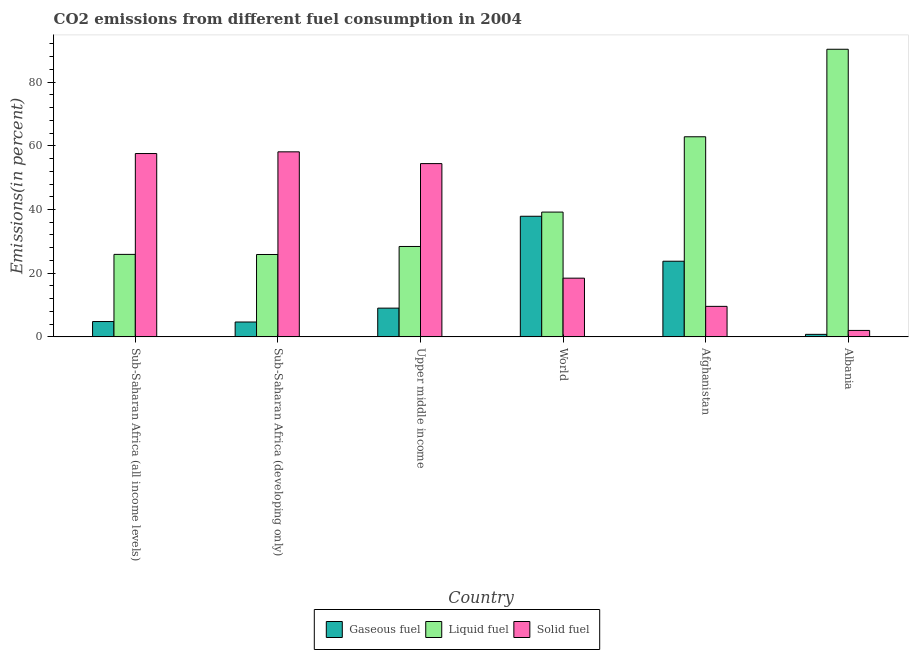How many different coloured bars are there?
Your response must be concise. 3. Are the number of bars per tick equal to the number of legend labels?
Give a very brief answer. Yes. What is the label of the 5th group of bars from the left?
Your answer should be compact. Afghanistan. In how many cases, is the number of bars for a given country not equal to the number of legend labels?
Provide a succinct answer. 0. What is the percentage of gaseous fuel emission in World?
Keep it short and to the point. 37.87. Across all countries, what is the maximum percentage of gaseous fuel emission?
Offer a terse response. 37.87. Across all countries, what is the minimum percentage of liquid fuel emission?
Your answer should be very brief. 25.87. In which country was the percentage of gaseous fuel emission maximum?
Your answer should be compact. World. In which country was the percentage of gaseous fuel emission minimum?
Keep it short and to the point. Albania. What is the total percentage of gaseous fuel emission in the graph?
Your response must be concise. 80.92. What is the difference between the percentage of liquid fuel emission in Albania and that in Sub-Saharan Africa (all income levels)?
Give a very brief answer. 64.41. What is the difference between the percentage of liquid fuel emission in Sub-Saharan Africa (all income levels) and the percentage of solid fuel emission in Upper middle income?
Your answer should be compact. -28.51. What is the average percentage of solid fuel emission per country?
Make the answer very short. 33.35. What is the difference between the percentage of gaseous fuel emission and percentage of liquid fuel emission in Sub-Saharan Africa (all income levels)?
Give a very brief answer. -21.09. What is the ratio of the percentage of gaseous fuel emission in Sub-Saharan Africa (all income levels) to that in World?
Offer a very short reply. 0.13. What is the difference between the highest and the second highest percentage of solid fuel emission?
Ensure brevity in your answer.  0.53. What is the difference between the highest and the lowest percentage of liquid fuel emission?
Ensure brevity in your answer.  64.45. Is the sum of the percentage of liquid fuel emission in Afghanistan and Albania greater than the maximum percentage of solid fuel emission across all countries?
Offer a terse response. Yes. What does the 3rd bar from the left in Albania represents?
Your response must be concise. Solid fuel. What does the 1st bar from the right in Sub-Saharan Africa (developing only) represents?
Offer a terse response. Solid fuel. Is it the case that in every country, the sum of the percentage of gaseous fuel emission and percentage of liquid fuel emission is greater than the percentage of solid fuel emission?
Your answer should be compact. No. Are all the bars in the graph horizontal?
Provide a short and direct response. No. What is the difference between two consecutive major ticks on the Y-axis?
Provide a short and direct response. 20. Does the graph contain any zero values?
Give a very brief answer. No. Does the graph contain grids?
Give a very brief answer. No. How are the legend labels stacked?
Provide a short and direct response. Horizontal. What is the title of the graph?
Offer a very short reply. CO2 emissions from different fuel consumption in 2004. Does "Machinery" appear as one of the legend labels in the graph?
Offer a terse response. No. What is the label or title of the Y-axis?
Make the answer very short. Emissions(in percent). What is the Emissions(in percent) of Gaseous fuel in Sub-Saharan Africa (all income levels)?
Make the answer very short. 4.81. What is the Emissions(in percent) in Liquid fuel in Sub-Saharan Africa (all income levels)?
Keep it short and to the point. 25.9. What is the Emissions(in percent) of Solid fuel in Sub-Saharan Africa (all income levels)?
Your response must be concise. 57.57. What is the Emissions(in percent) of Gaseous fuel in Sub-Saharan Africa (developing only)?
Provide a short and direct response. 4.67. What is the Emissions(in percent) in Liquid fuel in Sub-Saharan Africa (developing only)?
Provide a short and direct response. 25.87. What is the Emissions(in percent) in Solid fuel in Sub-Saharan Africa (developing only)?
Offer a terse response. 58.11. What is the Emissions(in percent) in Gaseous fuel in Upper middle income?
Ensure brevity in your answer.  9.03. What is the Emissions(in percent) in Liquid fuel in Upper middle income?
Keep it short and to the point. 28.38. What is the Emissions(in percent) of Solid fuel in Upper middle income?
Give a very brief answer. 54.41. What is the Emissions(in percent) in Gaseous fuel in World?
Your answer should be compact. 37.87. What is the Emissions(in percent) of Liquid fuel in World?
Provide a succinct answer. 39.18. What is the Emissions(in percent) in Solid fuel in World?
Make the answer very short. 18.44. What is the Emissions(in percent) of Gaseous fuel in Afghanistan?
Offer a very short reply. 23.75. What is the Emissions(in percent) in Liquid fuel in Afghanistan?
Ensure brevity in your answer.  62.84. What is the Emissions(in percent) of Solid fuel in Afghanistan?
Offer a terse response. 9.58. What is the Emissions(in percent) of Gaseous fuel in Albania?
Give a very brief answer. 0.79. What is the Emissions(in percent) of Liquid fuel in Albania?
Your answer should be very brief. 90.32. What is the Emissions(in percent) of Solid fuel in Albania?
Ensure brevity in your answer.  2.02. Across all countries, what is the maximum Emissions(in percent) in Gaseous fuel?
Offer a very short reply. 37.87. Across all countries, what is the maximum Emissions(in percent) in Liquid fuel?
Your answer should be compact. 90.32. Across all countries, what is the maximum Emissions(in percent) in Solid fuel?
Provide a succinct answer. 58.11. Across all countries, what is the minimum Emissions(in percent) in Gaseous fuel?
Offer a terse response. 0.79. Across all countries, what is the minimum Emissions(in percent) of Liquid fuel?
Your answer should be compact. 25.87. Across all countries, what is the minimum Emissions(in percent) in Solid fuel?
Give a very brief answer. 2.02. What is the total Emissions(in percent) in Gaseous fuel in the graph?
Keep it short and to the point. 80.92. What is the total Emissions(in percent) in Liquid fuel in the graph?
Your response must be concise. 272.49. What is the total Emissions(in percent) in Solid fuel in the graph?
Offer a very short reply. 200.13. What is the difference between the Emissions(in percent) of Gaseous fuel in Sub-Saharan Africa (all income levels) and that in Sub-Saharan Africa (developing only)?
Make the answer very short. 0.15. What is the difference between the Emissions(in percent) of Liquid fuel in Sub-Saharan Africa (all income levels) and that in Sub-Saharan Africa (developing only)?
Ensure brevity in your answer.  0.03. What is the difference between the Emissions(in percent) of Solid fuel in Sub-Saharan Africa (all income levels) and that in Sub-Saharan Africa (developing only)?
Provide a short and direct response. -0.53. What is the difference between the Emissions(in percent) in Gaseous fuel in Sub-Saharan Africa (all income levels) and that in Upper middle income?
Your answer should be very brief. -4.21. What is the difference between the Emissions(in percent) of Liquid fuel in Sub-Saharan Africa (all income levels) and that in Upper middle income?
Ensure brevity in your answer.  -2.48. What is the difference between the Emissions(in percent) in Solid fuel in Sub-Saharan Africa (all income levels) and that in Upper middle income?
Offer a very short reply. 3.16. What is the difference between the Emissions(in percent) of Gaseous fuel in Sub-Saharan Africa (all income levels) and that in World?
Your response must be concise. -33.06. What is the difference between the Emissions(in percent) of Liquid fuel in Sub-Saharan Africa (all income levels) and that in World?
Provide a short and direct response. -13.28. What is the difference between the Emissions(in percent) in Solid fuel in Sub-Saharan Africa (all income levels) and that in World?
Offer a very short reply. 39.14. What is the difference between the Emissions(in percent) of Gaseous fuel in Sub-Saharan Africa (all income levels) and that in Afghanistan?
Ensure brevity in your answer.  -18.94. What is the difference between the Emissions(in percent) of Liquid fuel in Sub-Saharan Africa (all income levels) and that in Afghanistan?
Provide a succinct answer. -36.93. What is the difference between the Emissions(in percent) of Solid fuel in Sub-Saharan Africa (all income levels) and that in Afghanistan?
Your response must be concise. 47.99. What is the difference between the Emissions(in percent) in Gaseous fuel in Sub-Saharan Africa (all income levels) and that in Albania?
Give a very brief answer. 4.02. What is the difference between the Emissions(in percent) in Liquid fuel in Sub-Saharan Africa (all income levels) and that in Albania?
Keep it short and to the point. -64.41. What is the difference between the Emissions(in percent) of Solid fuel in Sub-Saharan Africa (all income levels) and that in Albania?
Ensure brevity in your answer.  55.55. What is the difference between the Emissions(in percent) of Gaseous fuel in Sub-Saharan Africa (developing only) and that in Upper middle income?
Offer a terse response. -4.36. What is the difference between the Emissions(in percent) in Liquid fuel in Sub-Saharan Africa (developing only) and that in Upper middle income?
Your answer should be compact. -2.52. What is the difference between the Emissions(in percent) of Solid fuel in Sub-Saharan Africa (developing only) and that in Upper middle income?
Ensure brevity in your answer.  3.69. What is the difference between the Emissions(in percent) of Gaseous fuel in Sub-Saharan Africa (developing only) and that in World?
Your answer should be compact. -33.21. What is the difference between the Emissions(in percent) of Liquid fuel in Sub-Saharan Africa (developing only) and that in World?
Offer a very short reply. -13.32. What is the difference between the Emissions(in percent) of Solid fuel in Sub-Saharan Africa (developing only) and that in World?
Your response must be concise. 39.67. What is the difference between the Emissions(in percent) of Gaseous fuel in Sub-Saharan Africa (developing only) and that in Afghanistan?
Make the answer very short. -19.09. What is the difference between the Emissions(in percent) of Liquid fuel in Sub-Saharan Africa (developing only) and that in Afghanistan?
Ensure brevity in your answer.  -36.97. What is the difference between the Emissions(in percent) of Solid fuel in Sub-Saharan Africa (developing only) and that in Afghanistan?
Provide a succinct answer. 48.53. What is the difference between the Emissions(in percent) of Gaseous fuel in Sub-Saharan Africa (developing only) and that in Albania?
Give a very brief answer. 3.87. What is the difference between the Emissions(in percent) in Liquid fuel in Sub-Saharan Africa (developing only) and that in Albania?
Your answer should be compact. -64.45. What is the difference between the Emissions(in percent) in Solid fuel in Sub-Saharan Africa (developing only) and that in Albania?
Make the answer very short. 56.08. What is the difference between the Emissions(in percent) in Gaseous fuel in Upper middle income and that in World?
Your answer should be very brief. -28.85. What is the difference between the Emissions(in percent) of Liquid fuel in Upper middle income and that in World?
Provide a short and direct response. -10.8. What is the difference between the Emissions(in percent) of Solid fuel in Upper middle income and that in World?
Offer a terse response. 35.98. What is the difference between the Emissions(in percent) of Gaseous fuel in Upper middle income and that in Afghanistan?
Offer a very short reply. -14.73. What is the difference between the Emissions(in percent) of Liquid fuel in Upper middle income and that in Afghanistan?
Your response must be concise. -34.45. What is the difference between the Emissions(in percent) of Solid fuel in Upper middle income and that in Afghanistan?
Make the answer very short. 44.83. What is the difference between the Emissions(in percent) of Gaseous fuel in Upper middle income and that in Albania?
Offer a terse response. 8.23. What is the difference between the Emissions(in percent) in Liquid fuel in Upper middle income and that in Albania?
Offer a terse response. -61.93. What is the difference between the Emissions(in percent) of Solid fuel in Upper middle income and that in Albania?
Keep it short and to the point. 52.39. What is the difference between the Emissions(in percent) in Gaseous fuel in World and that in Afghanistan?
Your answer should be compact. 14.12. What is the difference between the Emissions(in percent) of Liquid fuel in World and that in Afghanistan?
Keep it short and to the point. -23.65. What is the difference between the Emissions(in percent) of Solid fuel in World and that in Afghanistan?
Make the answer very short. 8.86. What is the difference between the Emissions(in percent) in Gaseous fuel in World and that in Albania?
Your response must be concise. 37.08. What is the difference between the Emissions(in percent) of Liquid fuel in World and that in Albania?
Your response must be concise. -51.13. What is the difference between the Emissions(in percent) in Solid fuel in World and that in Albania?
Provide a succinct answer. 16.41. What is the difference between the Emissions(in percent) in Gaseous fuel in Afghanistan and that in Albania?
Offer a terse response. 22.96. What is the difference between the Emissions(in percent) in Liquid fuel in Afghanistan and that in Albania?
Your answer should be very brief. -27.48. What is the difference between the Emissions(in percent) in Solid fuel in Afghanistan and that in Albania?
Make the answer very short. 7.55. What is the difference between the Emissions(in percent) in Gaseous fuel in Sub-Saharan Africa (all income levels) and the Emissions(in percent) in Liquid fuel in Sub-Saharan Africa (developing only)?
Make the answer very short. -21.05. What is the difference between the Emissions(in percent) of Gaseous fuel in Sub-Saharan Africa (all income levels) and the Emissions(in percent) of Solid fuel in Sub-Saharan Africa (developing only)?
Make the answer very short. -53.29. What is the difference between the Emissions(in percent) of Liquid fuel in Sub-Saharan Africa (all income levels) and the Emissions(in percent) of Solid fuel in Sub-Saharan Africa (developing only)?
Keep it short and to the point. -32.2. What is the difference between the Emissions(in percent) of Gaseous fuel in Sub-Saharan Africa (all income levels) and the Emissions(in percent) of Liquid fuel in Upper middle income?
Ensure brevity in your answer.  -23.57. What is the difference between the Emissions(in percent) in Gaseous fuel in Sub-Saharan Africa (all income levels) and the Emissions(in percent) in Solid fuel in Upper middle income?
Provide a short and direct response. -49.6. What is the difference between the Emissions(in percent) in Liquid fuel in Sub-Saharan Africa (all income levels) and the Emissions(in percent) in Solid fuel in Upper middle income?
Provide a succinct answer. -28.51. What is the difference between the Emissions(in percent) in Gaseous fuel in Sub-Saharan Africa (all income levels) and the Emissions(in percent) in Liquid fuel in World?
Provide a short and direct response. -34.37. What is the difference between the Emissions(in percent) in Gaseous fuel in Sub-Saharan Africa (all income levels) and the Emissions(in percent) in Solid fuel in World?
Your answer should be very brief. -13.62. What is the difference between the Emissions(in percent) in Liquid fuel in Sub-Saharan Africa (all income levels) and the Emissions(in percent) in Solid fuel in World?
Give a very brief answer. 7.47. What is the difference between the Emissions(in percent) of Gaseous fuel in Sub-Saharan Africa (all income levels) and the Emissions(in percent) of Liquid fuel in Afghanistan?
Your answer should be compact. -58.02. What is the difference between the Emissions(in percent) of Gaseous fuel in Sub-Saharan Africa (all income levels) and the Emissions(in percent) of Solid fuel in Afghanistan?
Make the answer very short. -4.77. What is the difference between the Emissions(in percent) of Liquid fuel in Sub-Saharan Africa (all income levels) and the Emissions(in percent) of Solid fuel in Afghanistan?
Your answer should be very brief. 16.32. What is the difference between the Emissions(in percent) of Gaseous fuel in Sub-Saharan Africa (all income levels) and the Emissions(in percent) of Liquid fuel in Albania?
Provide a succinct answer. -85.5. What is the difference between the Emissions(in percent) of Gaseous fuel in Sub-Saharan Africa (all income levels) and the Emissions(in percent) of Solid fuel in Albania?
Your answer should be compact. 2.79. What is the difference between the Emissions(in percent) in Liquid fuel in Sub-Saharan Africa (all income levels) and the Emissions(in percent) in Solid fuel in Albania?
Offer a very short reply. 23.88. What is the difference between the Emissions(in percent) of Gaseous fuel in Sub-Saharan Africa (developing only) and the Emissions(in percent) of Liquid fuel in Upper middle income?
Your answer should be very brief. -23.72. What is the difference between the Emissions(in percent) in Gaseous fuel in Sub-Saharan Africa (developing only) and the Emissions(in percent) in Solid fuel in Upper middle income?
Keep it short and to the point. -49.74. What is the difference between the Emissions(in percent) of Liquid fuel in Sub-Saharan Africa (developing only) and the Emissions(in percent) of Solid fuel in Upper middle income?
Make the answer very short. -28.54. What is the difference between the Emissions(in percent) in Gaseous fuel in Sub-Saharan Africa (developing only) and the Emissions(in percent) in Liquid fuel in World?
Offer a terse response. -34.52. What is the difference between the Emissions(in percent) of Gaseous fuel in Sub-Saharan Africa (developing only) and the Emissions(in percent) of Solid fuel in World?
Offer a terse response. -13.77. What is the difference between the Emissions(in percent) of Liquid fuel in Sub-Saharan Africa (developing only) and the Emissions(in percent) of Solid fuel in World?
Offer a very short reply. 7.43. What is the difference between the Emissions(in percent) of Gaseous fuel in Sub-Saharan Africa (developing only) and the Emissions(in percent) of Liquid fuel in Afghanistan?
Keep it short and to the point. -58.17. What is the difference between the Emissions(in percent) in Gaseous fuel in Sub-Saharan Africa (developing only) and the Emissions(in percent) in Solid fuel in Afghanistan?
Offer a very short reply. -4.91. What is the difference between the Emissions(in percent) of Liquid fuel in Sub-Saharan Africa (developing only) and the Emissions(in percent) of Solid fuel in Afghanistan?
Provide a succinct answer. 16.29. What is the difference between the Emissions(in percent) in Gaseous fuel in Sub-Saharan Africa (developing only) and the Emissions(in percent) in Liquid fuel in Albania?
Keep it short and to the point. -85.65. What is the difference between the Emissions(in percent) of Gaseous fuel in Sub-Saharan Africa (developing only) and the Emissions(in percent) of Solid fuel in Albania?
Keep it short and to the point. 2.64. What is the difference between the Emissions(in percent) in Liquid fuel in Sub-Saharan Africa (developing only) and the Emissions(in percent) in Solid fuel in Albania?
Offer a terse response. 23.84. What is the difference between the Emissions(in percent) in Gaseous fuel in Upper middle income and the Emissions(in percent) in Liquid fuel in World?
Your answer should be compact. -30.16. What is the difference between the Emissions(in percent) of Gaseous fuel in Upper middle income and the Emissions(in percent) of Solid fuel in World?
Your response must be concise. -9.41. What is the difference between the Emissions(in percent) in Liquid fuel in Upper middle income and the Emissions(in percent) in Solid fuel in World?
Provide a succinct answer. 9.95. What is the difference between the Emissions(in percent) in Gaseous fuel in Upper middle income and the Emissions(in percent) in Liquid fuel in Afghanistan?
Offer a very short reply. -53.81. What is the difference between the Emissions(in percent) in Gaseous fuel in Upper middle income and the Emissions(in percent) in Solid fuel in Afghanistan?
Offer a terse response. -0.55. What is the difference between the Emissions(in percent) of Liquid fuel in Upper middle income and the Emissions(in percent) of Solid fuel in Afghanistan?
Make the answer very short. 18.81. What is the difference between the Emissions(in percent) of Gaseous fuel in Upper middle income and the Emissions(in percent) of Liquid fuel in Albania?
Give a very brief answer. -81.29. What is the difference between the Emissions(in percent) in Gaseous fuel in Upper middle income and the Emissions(in percent) in Solid fuel in Albania?
Offer a very short reply. 7. What is the difference between the Emissions(in percent) in Liquid fuel in Upper middle income and the Emissions(in percent) in Solid fuel in Albania?
Give a very brief answer. 26.36. What is the difference between the Emissions(in percent) in Gaseous fuel in World and the Emissions(in percent) in Liquid fuel in Afghanistan?
Provide a short and direct response. -24.96. What is the difference between the Emissions(in percent) of Gaseous fuel in World and the Emissions(in percent) of Solid fuel in Afghanistan?
Ensure brevity in your answer.  28.29. What is the difference between the Emissions(in percent) in Liquid fuel in World and the Emissions(in percent) in Solid fuel in Afghanistan?
Provide a succinct answer. 29.6. What is the difference between the Emissions(in percent) of Gaseous fuel in World and the Emissions(in percent) of Liquid fuel in Albania?
Provide a succinct answer. -52.44. What is the difference between the Emissions(in percent) in Gaseous fuel in World and the Emissions(in percent) in Solid fuel in Albania?
Make the answer very short. 35.85. What is the difference between the Emissions(in percent) in Liquid fuel in World and the Emissions(in percent) in Solid fuel in Albania?
Keep it short and to the point. 37.16. What is the difference between the Emissions(in percent) of Gaseous fuel in Afghanistan and the Emissions(in percent) of Liquid fuel in Albania?
Offer a terse response. -66.56. What is the difference between the Emissions(in percent) in Gaseous fuel in Afghanistan and the Emissions(in percent) in Solid fuel in Albania?
Make the answer very short. 21.73. What is the difference between the Emissions(in percent) of Liquid fuel in Afghanistan and the Emissions(in percent) of Solid fuel in Albania?
Offer a very short reply. 60.81. What is the average Emissions(in percent) in Gaseous fuel per country?
Offer a terse response. 13.49. What is the average Emissions(in percent) of Liquid fuel per country?
Your response must be concise. 45.41. What is the average Emissions(in percent) of Solid fuel per country?
Keep it short and to the point. 33.35. What is the difference between the Emissions(in percent) in Gaseous fuel and Emissions(in percent) in Liquid fuel in Sub-Saharan Africa (all income levels)?
Offer a very short reply. -21.09. What is the difference between the Emissions(in percent) of Gaseous fuel and Emissions(in percent) of Solid fuel in Sub-Saharan Africa (all income levels)?
Offer a terse response. -52.76. What is the difference between the Emissions(in percent) in Liquid fuel and Emissions(in percent) in Solid fuel in Sub-Saharan Africa (all income levels)?
Your answer should be very brief. -31.67. What is the difference between the Emissions(in percent) of Gaseous fuel and Emissions(in percent) of Liquid fuel in Sub-Saharan Africa (developing only)?
Provide a succinct answer. -21.2. What is the difference between the Emissions(in percent) in Gaseous fuel and Emissions(in percent) in Solid fuel in Sub-Saharan Africa (developing only)?
Offer a very short reply. -53.44. What is the difference between the Emissions(in percent) of Liquid fuel and Emissions(in percent) of Solid fuel in Sub-Saharan Africa (developing only)?
Your answer should be very brief. -32.24. What is the difference between the Emissions(in percent) of Gaseous fuel and Emissions(in percent) of Liquid fuel in Upper middle income?
Your answer should be compact. -19.36. What is the difference between the Emissions(in percent) of Gaseous fuel and Emissions(in percent) of Solid fuel in Upper middle income?
Offer a very short reply. -45.39. What is the difference between the Emissions(in percent) in Liquid fuel and Emissions(in percent) in Solid fuel in Upper middle income?
Offer a very short reply. -26.03. What is the difference between the Emissions(in percent) in Gaseous fuel and Emissions(in percent) in Liquid fuel in World?
Offer a very short reply. -1.31. What is the difference between the Emissions(in percent) in Gaseous fuel and Emissions(in percent) in Solid fuel in World?
Provide a short and direct response. 19.44. What is the difference between the Emissions(in percent) of Liquid fuel and Emissions(in percent) of Solid fuel in World?
Offer a very short reply. 20.75. What is the difference between the Emissions(in percent) of Gaseous fuel and Emissions(in percent) of Liquid fuel in Afghanistan?
Provide a short and direct response. -39.08. What is the difference between the Emissions(in percent) in Gaseous fuel and Emissions(in percent) in Solid fuel in Afghanistan?
Your answer should be very brief. 14.18. What is the difference between the Emissions(in percent) in Liquid fuel and Emissions(in percent) in Solid fuel in Afghanistan?
Make the answer very short. 53.26. What is the difference between the Emissions(in percent) in Gaseous fuel and Emissions(in percent) in Liquid fuel in Albania?
Your answer should be compact. -89.52. What is the difference between the Emissions(in percent) in Gaseous fuel and Emissions(in percent) in Solid fuel in Albania?
Ensure brevity in your answer.  -1.23. What is the difference between the Emissions(in percent) in Liquid fuel and Emissions(in percent) in Solid fuel in Albania?
Offer a terse response. 88.29. What is the ratio of the Emissions(in percent) of Gaseous fuel in Sub-Saharan Africa (all income levels) to that in Sub-Saharan Africa (developing only)?
Your answer should be compact. 1.03. What is the ratio of the Emissions(in percent) of Liquid fuel in Sub-Saharan Africa (all income levels) to that in Sub-Saharan Africa (developing only)?
Keep it short and to the point. 1. What is the ratio of the Emissions(in percent) in Solid fuel in Sub-Saharan Africa (all income levels) to that in Sub-Saharan Africa (developing only)?
Make the answer very short. 0.99. What is the ratio of the Emissions(in percent) of Gaseous fuel in Sub-Saharan Africa (all income levels) to that in Upper middle income?
Give a very brief answer. 0.53. What is the ratio of the Emissions(in percent) in Liquid fuel in Sub-Saharan Africa (all income levels) to that in Upper middle income?
Your response must be concise. 0.91. What is the ratio of the Emissions(in percent) in Solid fuel in Sub-Saharan Africa (all income levels) to that in Upper middle income?
Give a very brief answer. 1.06. What is the ratio of the Emissions(in percent) in Gaseous fuel in Sub-Saharan Africa (all income levels) to that in World?
Provide a short and direct response. 0.13. What is the ratio of the Emissions(in percent) in Liquid fuel in Sub-Saharan Africa (all income levels) to that in World?
Give a very brief answer. 0.66. What is the ratio of the Emissions(in percent) of Solid fuel in Sub-Saharan Africa (all income levels) to that in World?
Offer a terse response. 3.12. What is the ratio of the Emissions(in percent) of Gaseous fuel in Sub-Saharan Africa (all income levels) to that in Afghanistan?
Provide a short and direct response. 0.2. What is the ratio of the Emissions(in percent) in Liquid fuel in Sub-Saharan Africa (all income levels) to that in Afghanistan?
Make the answer very short. 0.41. What is the ratio of the Emissions(in percent) of Solid fuel in Sub-Saharan Africa (all income levels) to that in Afghanistan?
Your answer should be compact. 6.01. What is the ratio of the Emissions(in percent) of Gaseous fuel in Sub-Saharan Africa (all income levels) to that in Albania?
Provide a short and direct response. 6.08. What is the ratio of the Emissions(in percent) in Liquid fuel in Sub-Saharan Africa (all income levels) to that in Albania?
Your answer should be very brief. 0.29. What is the ratio of the Emissions(in percent) in Solid fuel in Sub-Saharan Africa (all income levels) to that in Albania?
Offer a terse response. 28.44. What is the ratio of the Emissions(in percent) in Gaseous fuel in Sub-Saharan Africa (developing only) to that in Upper middle income?
Keep it short and to the point. 0.52. What is the ratio of the Emissions(in percent) of Liquid fuel in Sub-Saharan Africa (developing only) to that in Upper middle income?
Your answer should be compact. 0.91. What is the ratio of the Emissions(in percent) of Solid fuel in Sub-Saharan Africa (developing only) to that in Upper middle income?
Offer a very short reply. 1.07. What is the ratio of the Emissions(in percent) of Gaseous fuel in Sub-Saharan Africa (developing only) to that in World?
Provide a succinct answer. 0.12. What is the ratio of the Emissions(in percent) of Liquid fuel in Sub-Saharan Africa (developing only) to that in World?
Your answer should be compact. 0.66. What is the ratio of the Emissions(in percent) of Solid fuel in Sub-Saharan Africa (developing only) to that in World?
Your answer should be very brief. 3.15. What is the ratio of the Emissions(in percent) of Gaseous fuel in Sub-Saharan Africa (developing only) to that in Afghanistan?
Provide a succinct answer. 0.2. What is the ratio of the Emissions(in percent) in Liquid fuel in Sub-Saharan Africa (developing only) to that in Afghanistan?
Your response must be concise. 0.41. What is the ratio of the Emissions(in percent) of Solid fuel in Sub-Saharan Africa (developing only) to that in Afghanistan?
Provide a succinct answer. 6.07. What is the ratio of the Emissions(in percent) of Gaseous fuel in Sub-Saharan Africa (developing only) to that in Albania?
Offer a very short reply. 5.89. What is the ratio of the Emissions(in percent) of Liquid fuel in Sub-Saharan Africa (developing only) to that in Albania?
Give a very brief answer. 0.29. What is the ratio of the Emissions(in percent) of Solid fuel in Sub-Saharan Africa (developing only) to that in Albania?
Give a very brief answer. 28.7. What is the ratio of the Emissions(in percent) in Gaseous fuel in Upper middle income to that in World?
Provide a succinct answer. 0.24. What is the ratio of the Emissions(in percent) in Liquid fuel in Upper middle income to that in World?
Your response must be concise. 0.72. What is the ratio of the Emissions(in percent) of Solid fuel in Upper middle income to that in World?
Make the answer very short. 2.95. What is the ratio of the Emissions(in percent) in Gaseous fuel in Upper middle income to that in Afghanistan?
Your response must be concise. 0.38. What is the ratio of the Emissions(in percent) of Liquid fuel in Upper middle income to that in Afghanistan?
Your response must be concise. 0.45. What is the ratio of the Emissions(in percent) in Solid fuel in Upper middle income to that in Afghanistan?
Give a very brief answer. 5.68. What is the ratio of the Emissions(in percent) of Gaseous fuel in Upper middle income to that in Albania?
Provide a short and direct response. 11.39. What is the ratio of the Emissions(in percent) in Liquid fuel in Upper middle income to that in Albania?
Provide a succinct answer. 0.31. What is the ratio of the Emissions(in percent) of Solid fuel in Upper middle income to that in Albania?
Give a very brief answer. 26.87. What is the ratio of the Emissions(in percent) in Gaseous fuel in World to that in Afghanistan?
Provide a short and direct response. 1.59. What is the ratio of the Emissions(in percent) in Liquid fuel in World to that in Afghanistan?
Your response must be concise. 0.62. What is the ratio of the Emissions(in percent) of Solid fuel in World to that in Afghanistan?
Keep it short and to the point. 1.92. What is the ratio of the Emissions(in percent) in Gaseous fuel in World to that in Albania?
Make the answer very short. 47.8. What is the ratio of the Emissions(in percent) of Liquid fuel in World to that in Albania?
Provide a short and direct response. 0.43. What is the ratio of the Emissions(in percent) in Solid fuel in World to that in Albania?
Make the answer very short. 9.11. What is the ratio of the Emissions(in percent) in Gaseous fuel in Afghanistan to that in Albania?
Offer a very short reply. 29.98. What is the ratio of the Emissions(in percent) in Liquid fuel in Afghanistan to that in Albania?
Provide a short and direct response. 0.7. What is the ratio of the Emissions(in percent) of Solid fuel in Afghanistan to that in Albania?
Your answer should be very brief. 4.73. What is the difference between the highest and the second highest Emissions(in percent) in Gaseous fuel?
Your response must be concise. 14.12. What is the difference between the highest and the second highest Emissions(in percent) of Liquid fuel?
Your answer should be very brief. 27.48. What is the difference between the highest and the second highest Emissions(in percent) of Solid fuel?
Your response must be concise. 0.53. What is the difference between the highest and the lowest Emissions(in percent) in Gaseous fuel?
Give a very brief answer. 37.08. What is the difference between the highest and the lowest Emissions(in percent) in Liquid fuel?
Keep it short and to the point. 64.45. What is the difference between the highest and the lowest Emissions(in percent) in Solid fuel?
Provide a short and direct response. 56.08. 